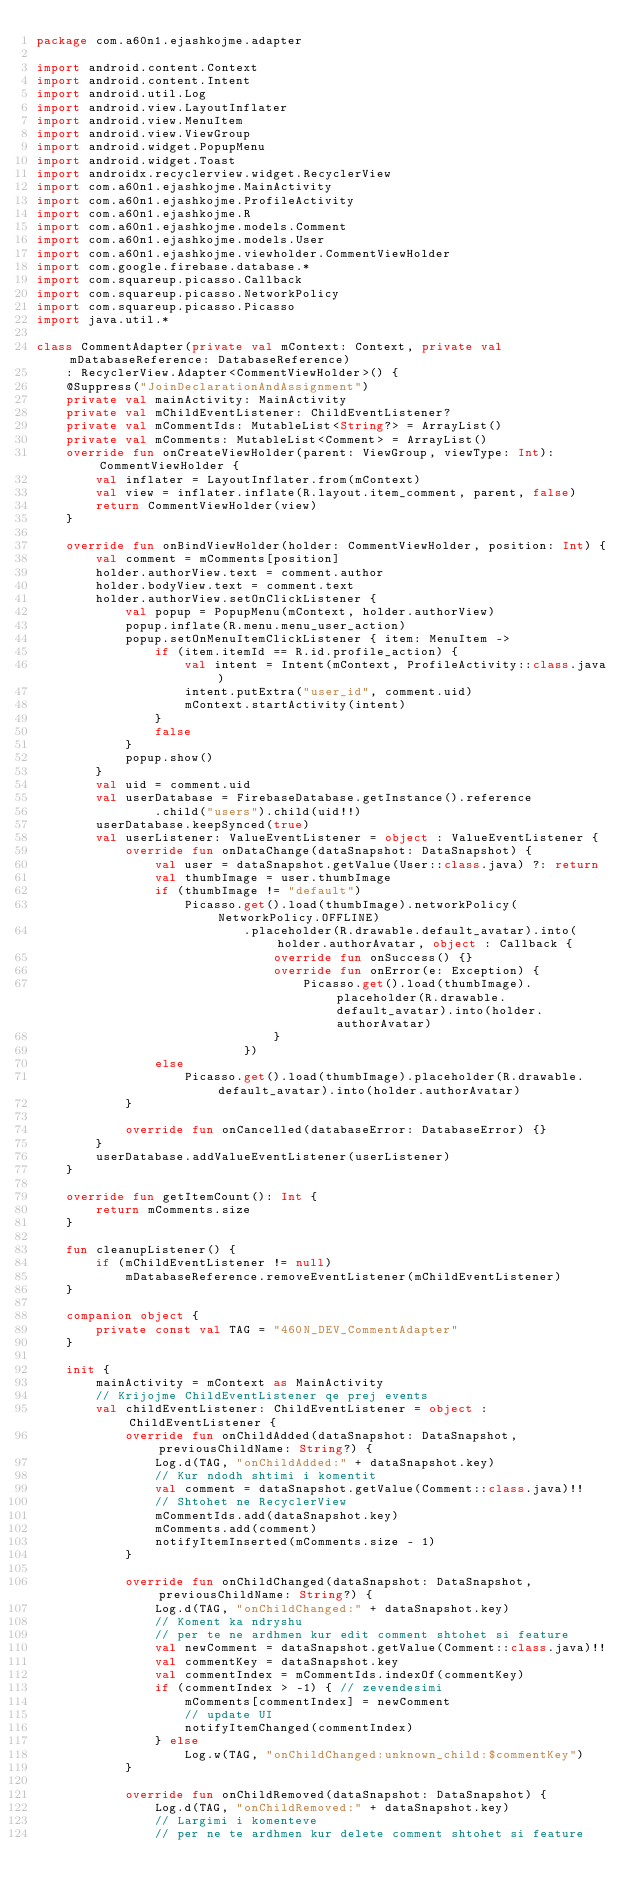<code> <loc_0><loc_0><loc_500><loc_500><_Kotlin_>package com.a60n1.ejashkojme.adapter

import android.content.Context
import android.content.Intent
import android.util.Log
import android.view.LayoutInflater
import android.view.MenuItem
import android.view.ViewGroup
import android.widget.PopupMenu
import android.widget.Toast
import androidx.recyclerview.widget.RecyclerView
import com.a60n1.ejashkojme.MainActivity
import com.a60n1.ejashkojme.ProfileActivity
import com.a60n1.ejashkojme.R
import com.a60n1.ejashkojme.models.Comment
import com.a60n1.ejashkojme.models.User
import com.a60n1.ejashkojme.viewholder.CommentViewHolder
import com.google.firebase.database.*
import com.squareup.picasso.Callback
import com.squareup.picasso.NetworkPolicy
import com.squareup.picasso.Picasso
import java.util.*

class CommentAdapter(private val mContext: Context, private val mDatabaseReference: DatabaseReference)
    : RecyclerView.Adapter<CommentViewHolder>() {
    @Suppress("JoinDeclarationAndAssignment")
    private val mainActivity: MainActivity
    private val mChildEventListener: ChildEventListener?
    private val mCommentIds: MutableList<String?> = ArrayList()
    private val mComments: MutableList<Comment> = ArrayList()
    override fun onCreateViewHolder(parent: ViewGroup, viewType: Int): CommentViewHolder {
        val inflater = LayoutInflater.from(mContext)
        val view = inflater.inflate(R.layout.item_comment, parent, false)
        return CommentViewHolder(view)
    }

    override fun onBindViewHolder(holder: CommentViewHolder, position: Int) {
        val comment = mComments[position]
        holder.authorView.text = comment.author
        holder.bodyView.text = comment.text
        holder.authorView.setOnClickListener {
            val popup = PopupMenu(mContext, holder.authorView)
            popup.inflate(R.menu.menu_user_action)
            popup.setOnMenuItemClickListener { item: MenuItem ->
                if (item.itemId == R.id.profile_action) {
                    val intent = Intent(mContext, ProfileActivity::class.java)
                    intent.putExtra("user_id", comment.uid)
                    mContext.startActivity(intent)
                }
                false
            }
            popup.show()
        }
        val uid = comment.uid
        val userDatabase = FirebaseDatabase.getInstance().reference
                .child("users").child(uid!!)
        userDatabase.keepSynced(true)
        val userListener: ValueEventListener = object : ValueEventListener {
            override fun onDataChange(dataSnapshot: DataSnapshot) {
                val user = dataSnapshot.getValue(User::class.java) ?: return
                val thumbImage = user.thumbImage
                if (thumbImage != "default")
                    Picasso.get().load(thumbImage).networkPolicy(NetworkPolicy.OFFLINE)
                            .placeholder(R.drawable.default_avatar).into(holder.authorAvatar, object : Callback {
                                override fun onSuccess() {}
                                override fun onError(e: Exception) {
                                    Picasso.get().load(thumbImage).placeholder(R.drawable.default_avatar).into(holder.authorAvatar)
                                }
                            })
                else
                    Picasso.get().load(thumbImage).placeholder(R.drawable.default_avatar).into(holder.authorAvatar)
            }

            override fun onCancelled(databaseError: DatabaseError) {}
        }
        userDatabase.addValueEventListener(userListener)
    }

    override fun getItemCount(): Int {
        return mComments.size
    }

    fun cleanupListener() {
        if (mChildEventListener != null)
            mDatabaseReference.removeEventListener(mChildEventListener)
    }

    companion object {
        private const val TAG = "460N_DEV_CommentAdapter"
    }

    init {
        mainActivity = mContext as MainActivity
        // Krijojme ChildEventListener qe prej events
        val childEventListener: ChildEventListener = object : ChildEventListener {
            override fun onChildAdded(dataSnapshot: DataSnapshot, previousChildName: String?) {
                Log.d(TAG, "onChildAdded:" + dataSnapshot.key)
                // Kur ndodh shtimi i komentit
                val comment = dataSnapshot.getValue(Comment::class.java)!!
                // Shtohet ne RecyclerView
                mCommentIds.add(dataSnapshot.key)
                mComments.add(comment)
                notifyItemInserted(mComments.size - 1)
            }

            override fun onChildChanged(dataSnapshot: DataSnapshot, previousChildName: String?) {
                Log.d(TAG, "onChildChanged:" + dataSnapshot.key)
                // Koment ka ndryshu
                // per te ne ardhmen kur edit comment shtohet si feature
                val newComment = dataSnapshot.getValue(Comment::class.java)!!
                val commentKey = dataSnapshot.key
                val commentIndex = mCommentIds.indexOf(commentKey)
                if (commentIndex > -1) { // zevendesimi
                    mComments[commentIndex] = newComment
                    // update UI
                    notifyItemChanged(commentIndex)
                } else
                    Log.w(TAG, "onChildChanged:unknown_child:$commentKey")
            }

            override fun onChildRemoved(dataSnapshot: DataSnapshot) {
                Log.d(TAG, "onChildRemoved:" + dataSnapshot.key)
                // Largimi i komenteve
                // per ne te ardhmen kur delete comment shtohet si feature</code> 